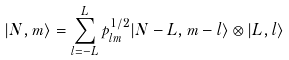<formula> <loc_0><loc_0><loc_500><loc_500>| N , m \rangle = \sum _ { l = - L } ^ { L } p _ { l m } ^ { 1 / 2 } | N - L , m - l \rangle \otimes | L , l \rangle</formula> 